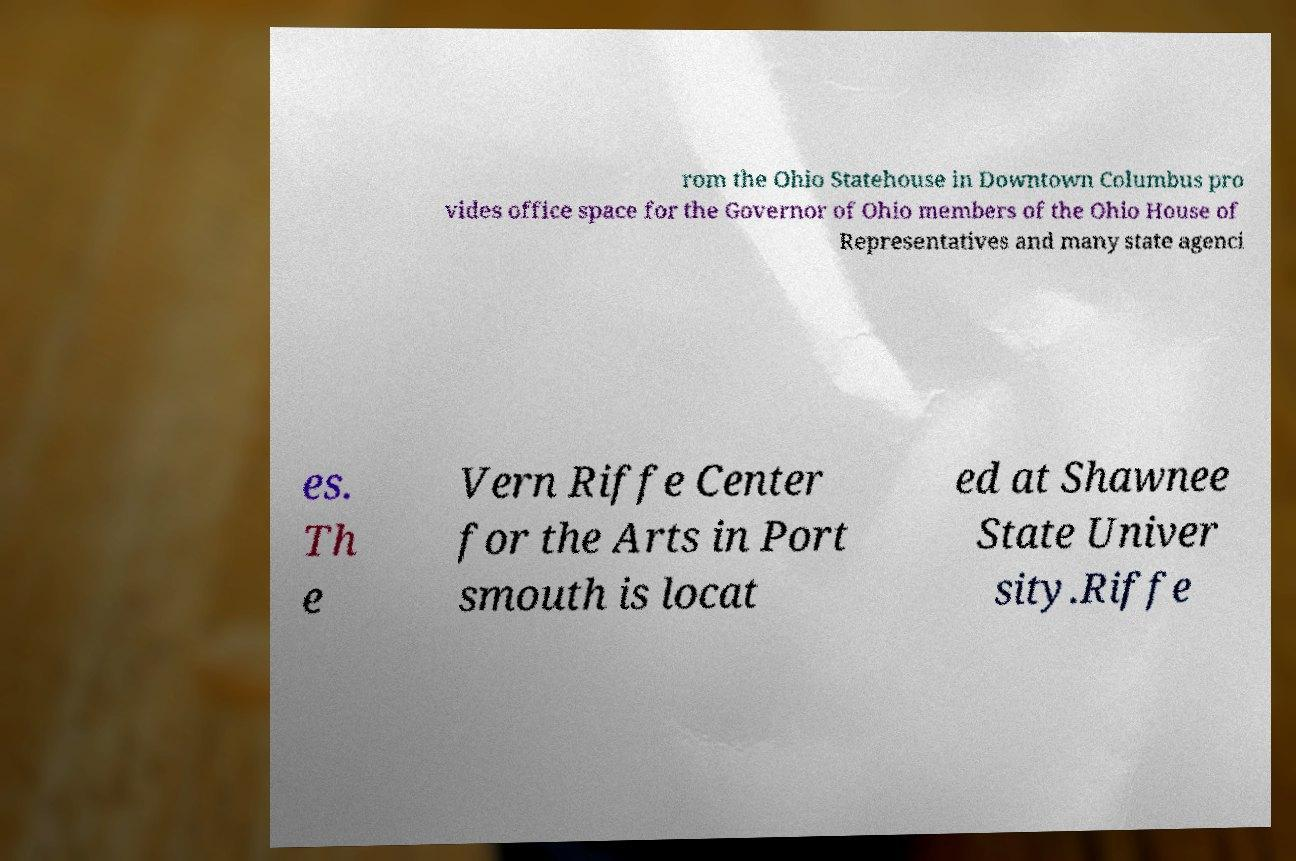I need the written content from this picture converted into text. Can you do that? rom the Ohio Statehouse in Downtown Columbus pro vides office space for the Governor of Ohio members of the Ohio House of Representatives and many state agenci es. Th e Vern Riffe Center for the Arts in Port smouth is locat ed at Shawnee State Univer sity.Riffe 